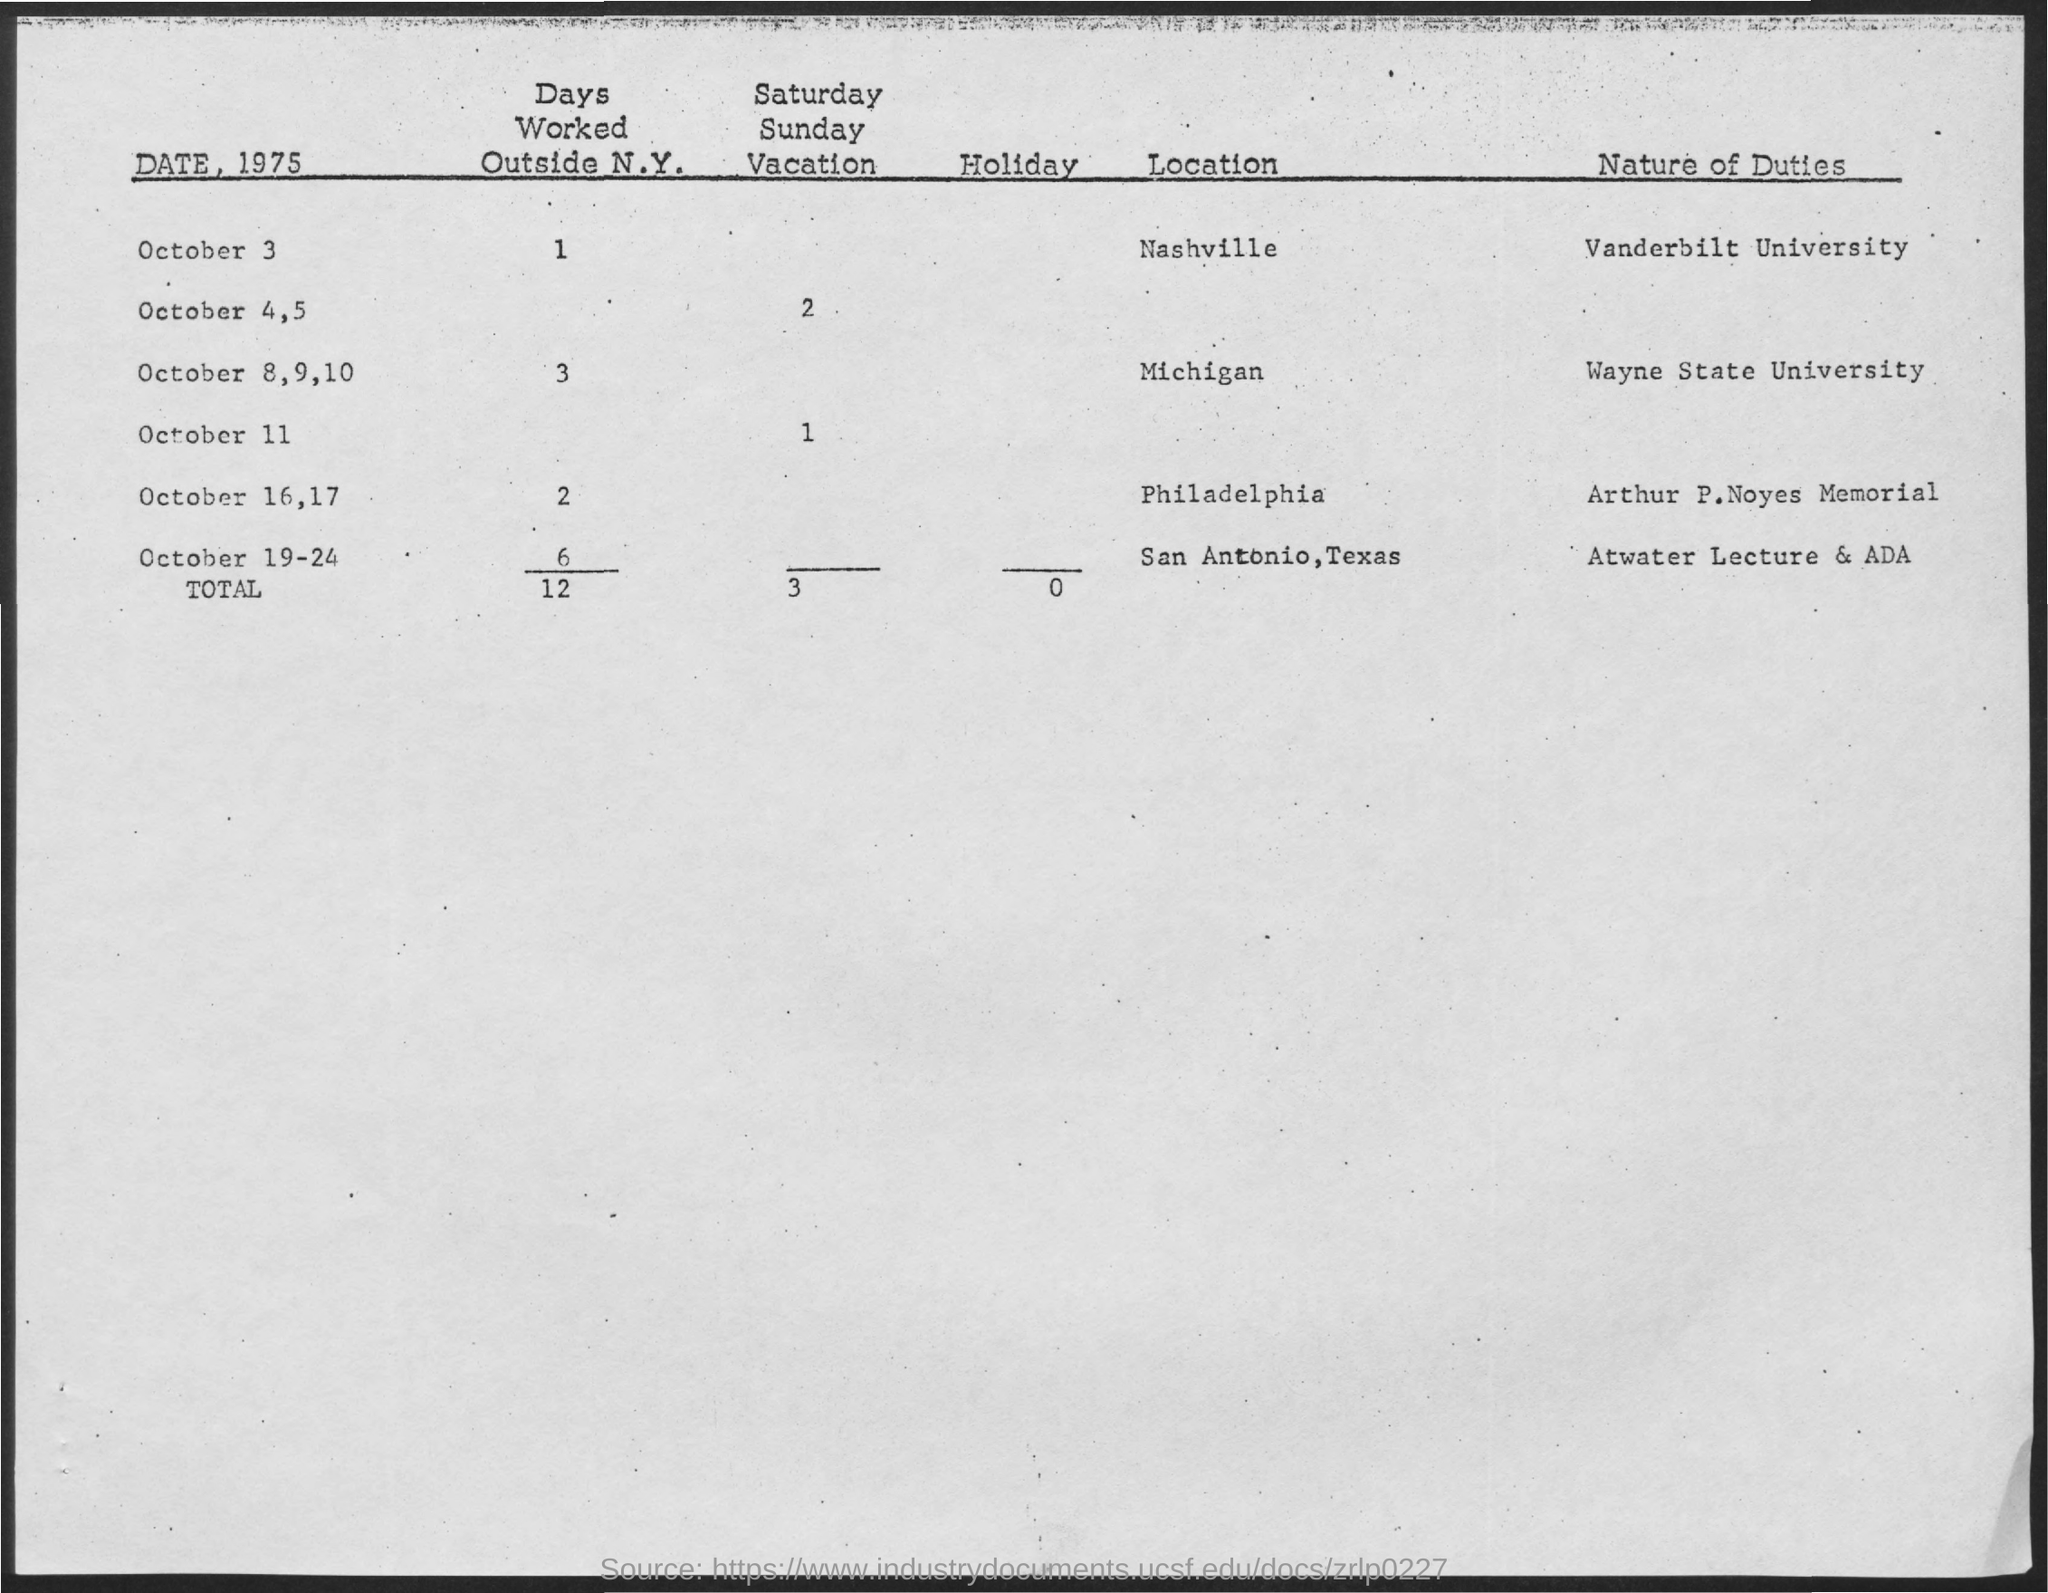What is the total number of days worked outside N.Y.?
Give a very brief answer. 12. What is the total number of Holidays?
Ensure brevity in your answer.  0. What is the nature of duty on October 3?
Provide a succinct answer. Vanderbilt university. What is the location on October 3?
Your answer should be compact. Nashville. What is the nature of duty on October 8-10?
Offer a very short reply. Wayne state university. What is the number of days worked outside N.Y. on October 3?
Make the answer very short. 1. 